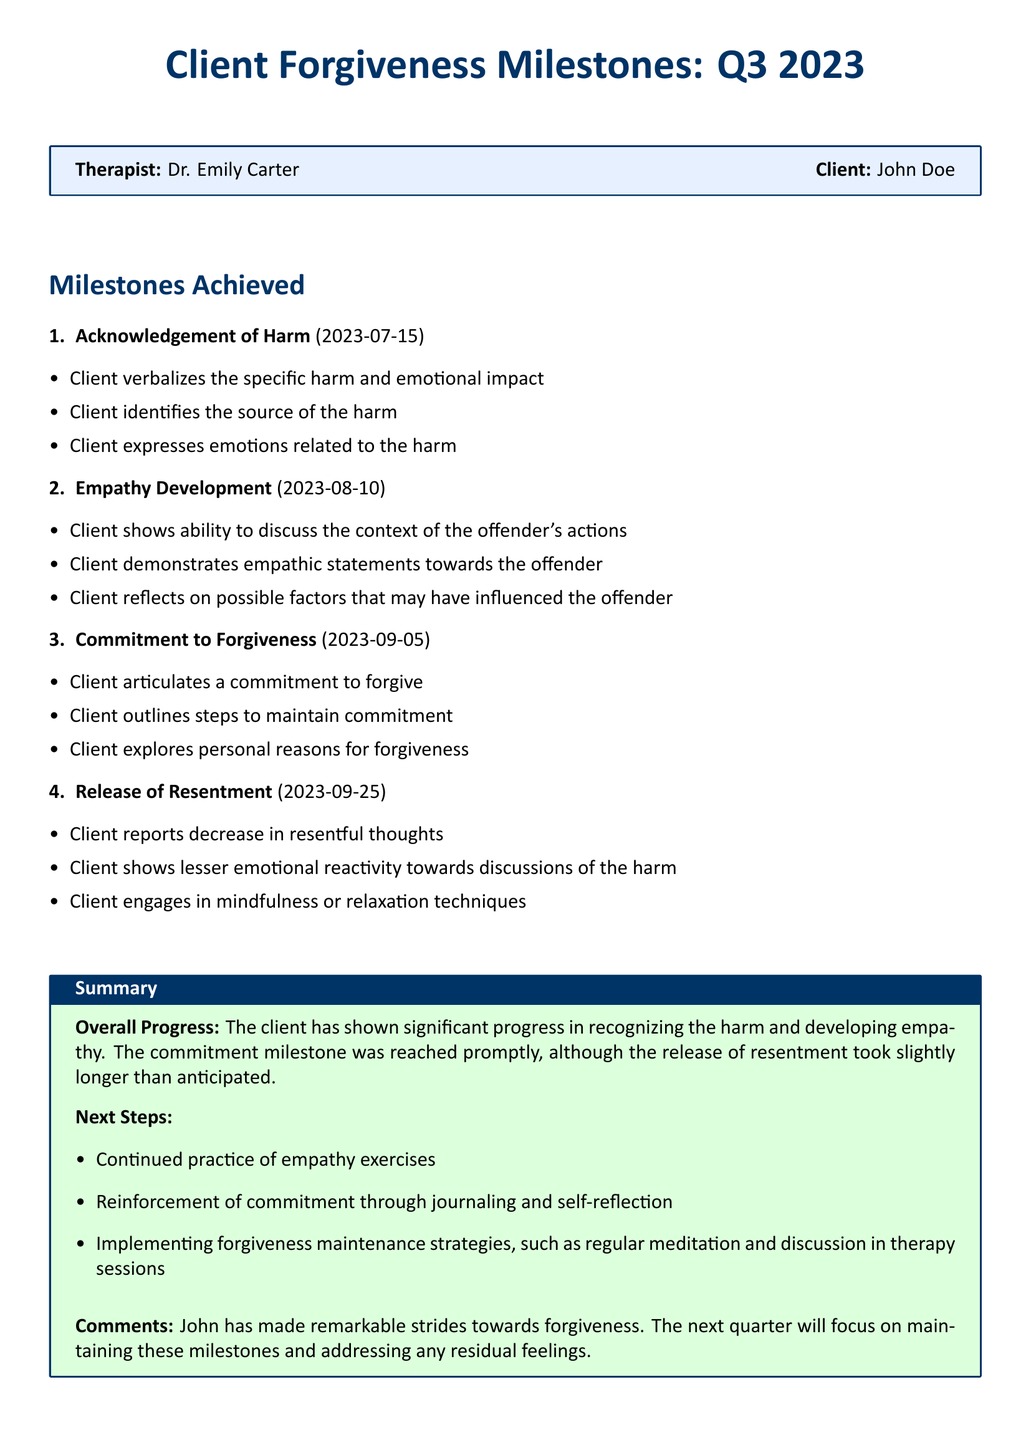What is the client's name? The client's name is explicitly mentioned in the document under the therapist information.
Answer: John Doe What was the date of the Acknowledgement of Harm milestone? The date is listed alongside the milestone in the document.
Answer: 2023-07-15 How many milestones were achieved by the client? The total number of milestones is indicated by the numbering in the milestones section.
Answer: 4 What is the overall progress noted for the client? The overall progress is summarized in the box at the bottom of the document.
Answer: Significant progress Which milestone focused on the commitment to forgive? This can be found by referring to the listed milestones in the document.
Answer: Commitment to Forgiveness What is one of the next steps listed for the client? The next steps are outlined in the summary box and can include various strategies.
Answer: Continued practice of empathy exercises What was the date of the Release of Resentment milestone? The date can be located within the milestones section of the document.
Answer: 2023-09-25 Who is the therapist associated with the client? The therapist's name is provided in the introductory box of the document.
Answer: Dr. Emily Carter What did the client report regarding resentful thoughts? This information is part of the milestones achieved section, reflecting the client's experience.
Answer: Decrease in resentful thoughts 